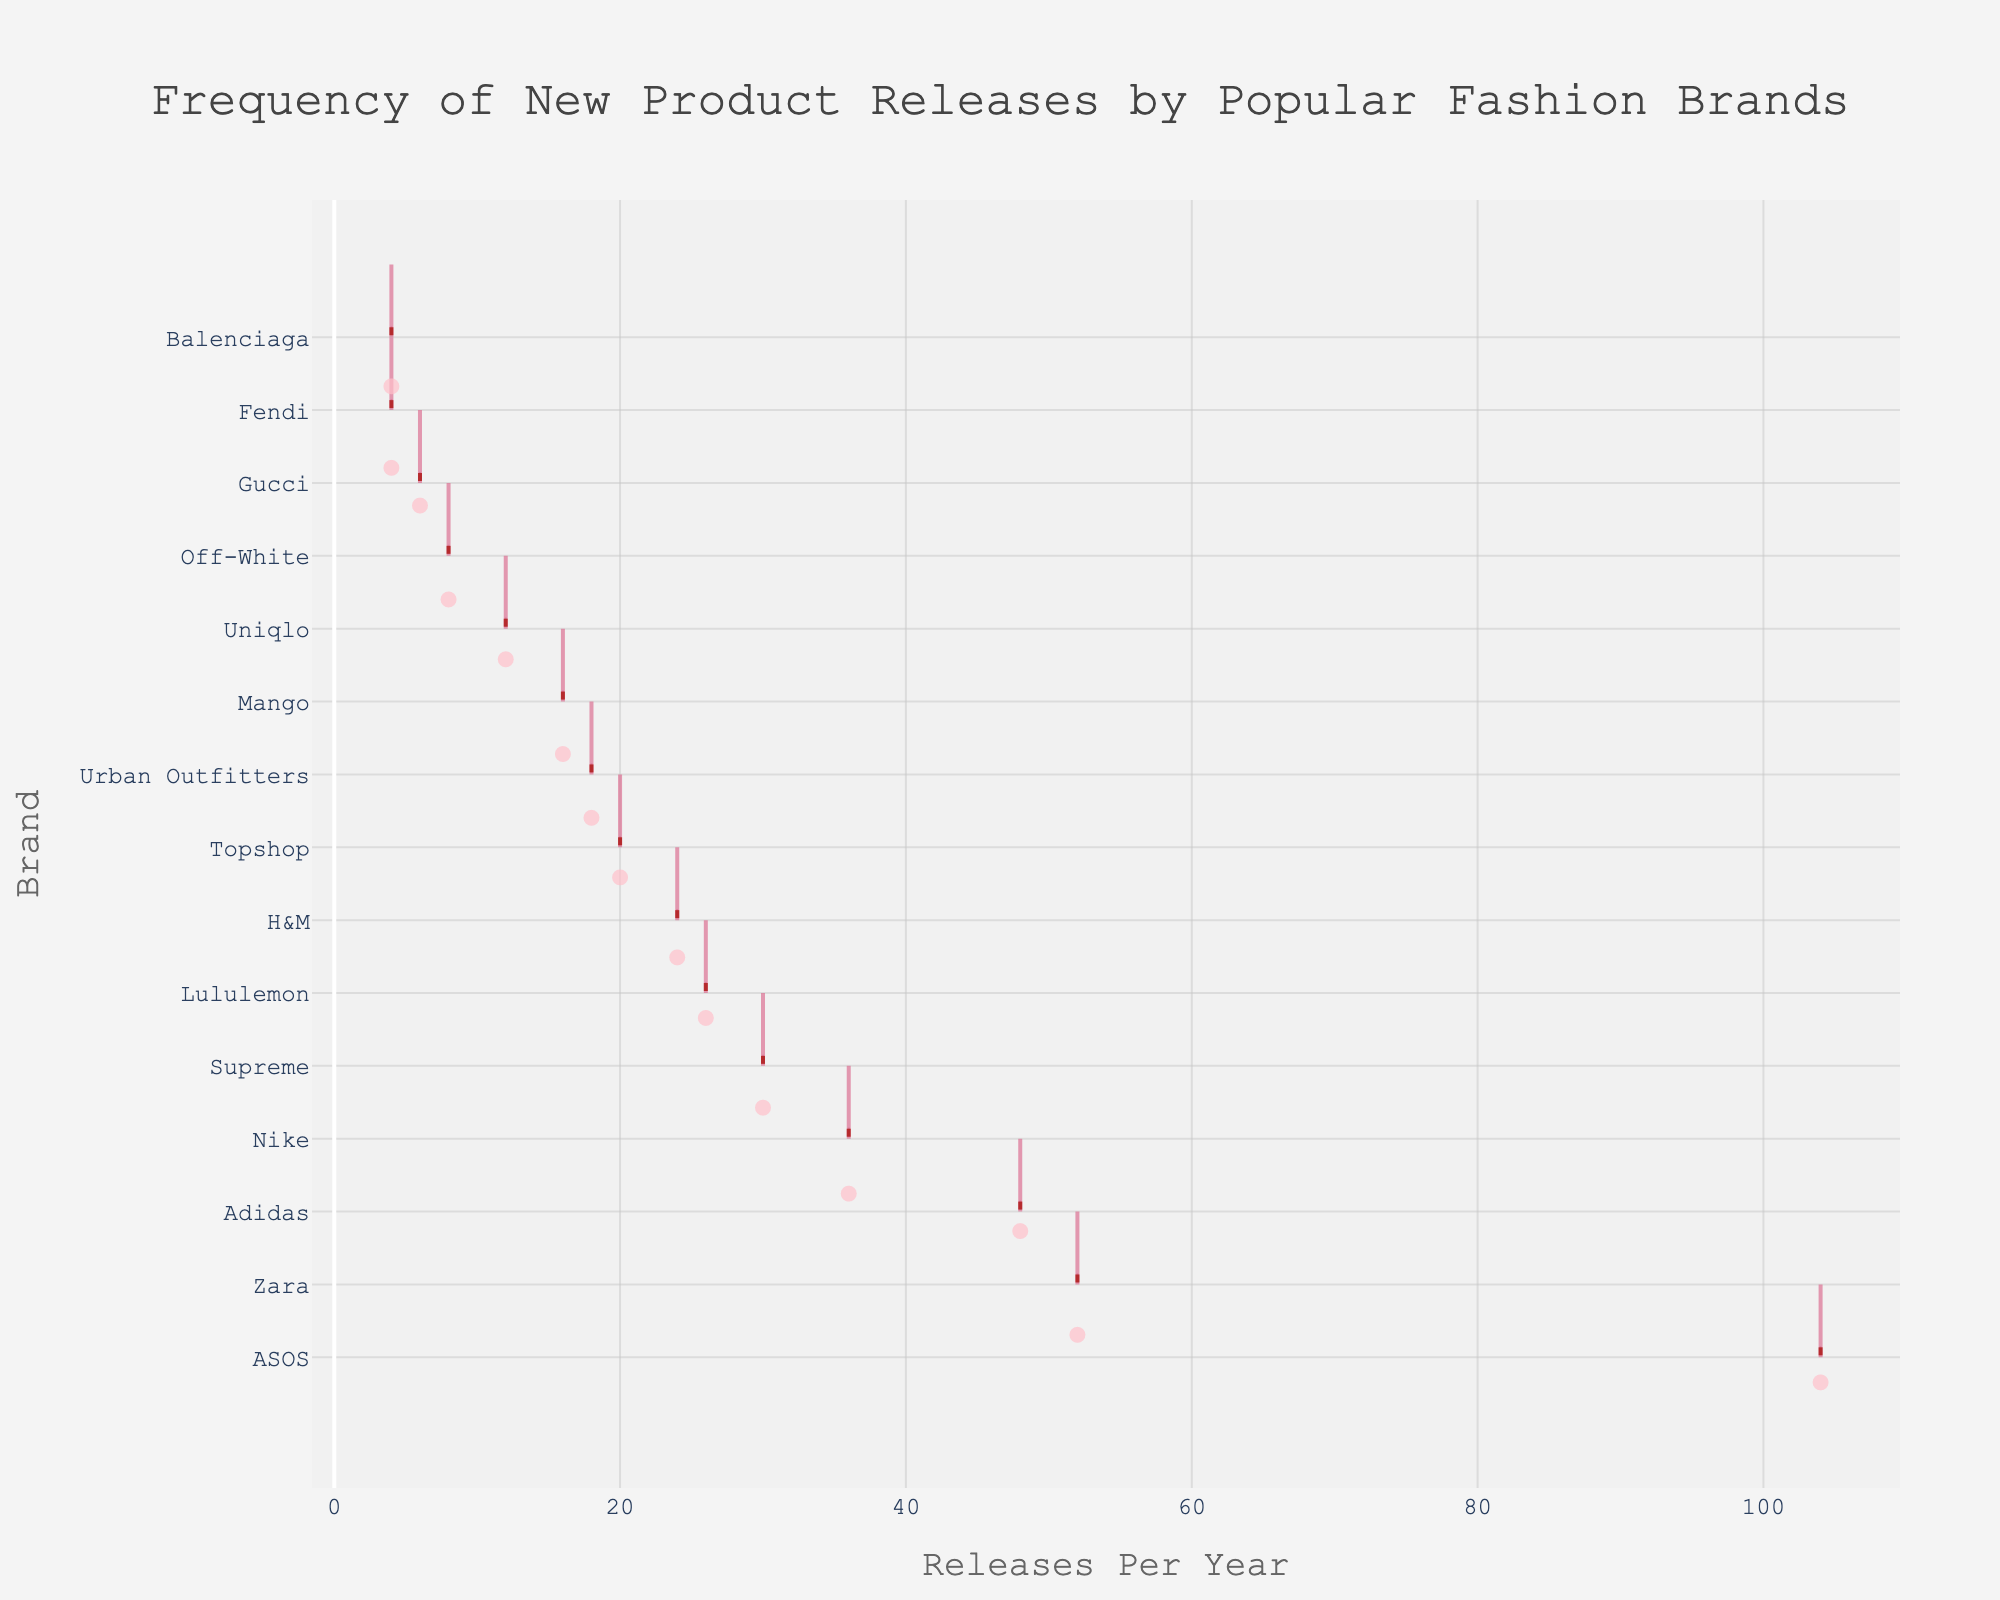What is the title of the plot? Look at the top of the plot where the title is positioned. The title usually provides a summary of the plot's content.
Answer: Frequency of New Product Releases by Popular Fashion Brands Which brand has the highest number of releases per year? Identify the brand with the highest value on the x-axis, as sorted in the figure.
Answer: ASOS How many releases per year does Gucci have? Find the data point associated with Gucci on the y-axis and check its position on the x-axis.
Answer: 6 Which brands have fewer than 10 releases per year? Locate the data points on the x-axis that are less than 10 and identify their corresponding brands on the y-axis.
Answer: Fendi, Balenciaga Which brand releases about twice as many products per year as Supreme? Determine the number of releases for Supreme and find a brand with approximately double that number on the x-axis.
Answer: Adidas How does Zara's release frequency compare to H&M's? Compare the position of Zara and H&M on the x-axis to see which one is greater.
Answer: Zara has more releases than H&M Are there any brands with the same number of product releases per year? If so, list them. Check if there are any overlapping data points on the x-axis and list the corresponding brands from the y-axis.
Answer: Fendi and Balenciaga both have 4 releases per year What is the average number of releases per year for the listed brands? Sum up all the releases per year for each brand and divide by the total number of brands (15).
Answer: (52 + 24 + 36 + 6 + 30 + 48 + 12 + 4 + 8 + 4 + 18 + 20 + 26 + 16 + 104) / 15 = 27.47 Which brands are below the average releases per year? Compare each brand's release frequency to the average value calculated.
Answer: Gucci, Uniqlo, Fendi, Off-White, Balenciaga, Urban Outfitters, Mango How many brands have 20 or more releases per year? Find all data points on the x-axis that are equal to or greater than 20 and count the corresponding brands on the y-axis.
Answer: 8 